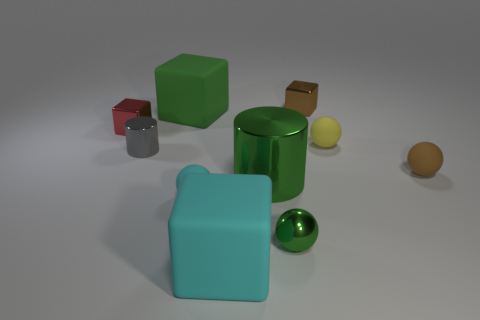Could there be a symbolic meaning behind the placement and color of these objects, or is it purely aesthetic? Each object's placement and color could symbolize various concepts such as diversity or unity in contrast. However, without explicit context from the artist, it is also plausible that the arrangement is intended purely for aesthetic purposes, to create a visual appeal through the use of geometrical shapes and a selective color palette. 